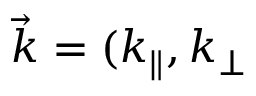<formula> <loc_0><loc_0><loc_500><loc_500>\vec { k } = ( k _ { \| } , k _ { \perp }</formula> 